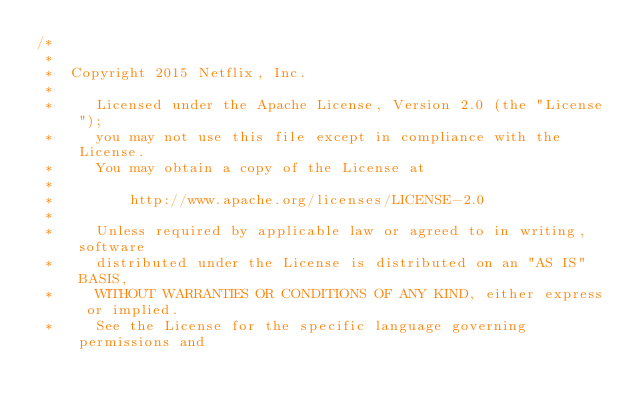Convert code to text. <code><loc_0><loc_0><loc_500><loc_500><_Java_>/*
 *
 *  Copyright 2015 Netflix, Inc.
 *
 *     Licensed under the Apache License, Version 2.0 (the "License");
 *     you may not use this file except in compliance with the License.
 *     You may obtain a copy of the License at
 *
 *         http://www.apache.org/licenses/LICENSE-2.0
 *
 *     Unless required by applicable law or agreed to in writing, software
 *     distributed under the License is distributed on an "AS IS" BASIS,
 *     WITHOUT WARRANTIES OR CONDITIONS OF ANY KIND, either express or implied.
 *     See the License for the specific language governing permissions and</code> 